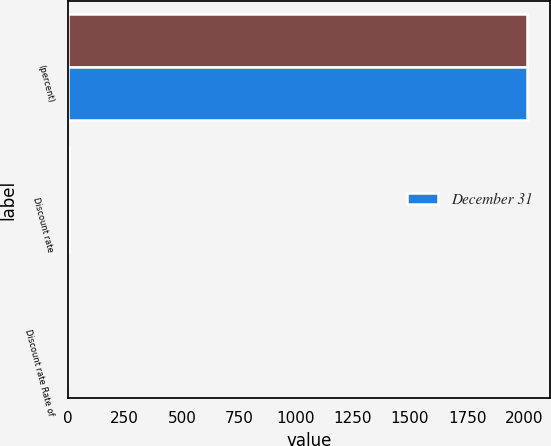Convert chart. <chart><loc_0><loc_0><loc_500><loc_500><stacked_bar_chart><ecel><fcel>(percent)<fcel>Discount rate<fcel>Discount rate Rate of<nl><fcel>nan<fcel>2012<fcel>3.67<fcel>2.72<nl><fcel>December 31<fcel>2011<fcel>4.42<fcel>2.78<nl></chart> 